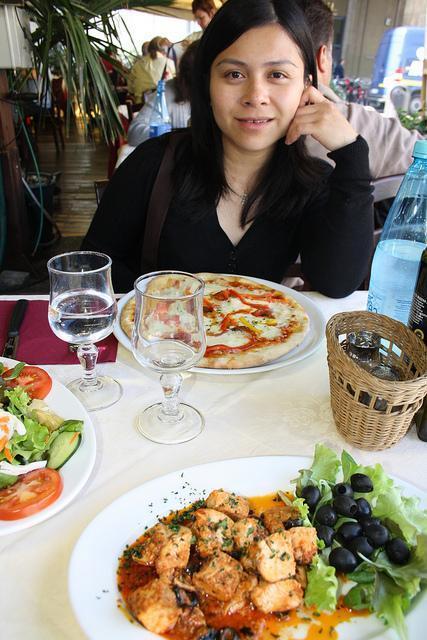Is the statement "The dining table is away from the potted plant." accurate regarding the image?
Answer yes or no. Yes. 